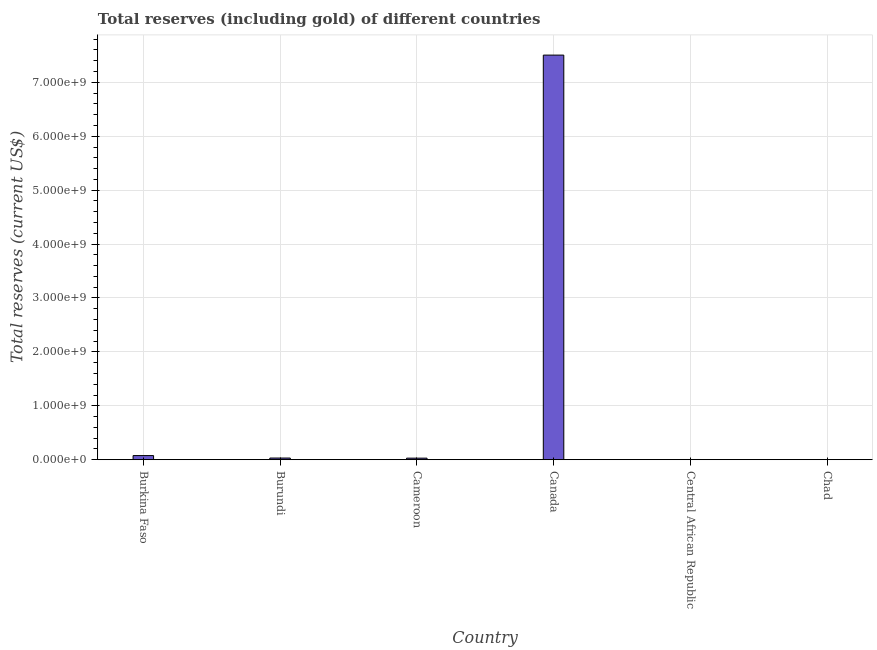What is the title of the graph?
Keep it short and to the point. Total reserves (including gold) of different countries. What is the label or title of the X-axis?
Offer a very short reply. Country. What is the label or title of the Y-axis?
Your response must be concise. Total reserves (current US$). What is the total reserves (including gold) in Central African Republic?
Give a very brief answer. 3.83e+06. Across all countries, what is the maximum total reserves (including gold)?
Keep it short and to the point. 7.50e+09. Across all countries, what is the minimum total reserves (including gold)?
Your response must be concise. 3.06e+06. In which country was the total reserves (including gold) maximum?
Provide a succinct answer. Canada. In which country was the total reserves (including gold) minimum?
Offer a terse response. Chad. What is the sum of the total reserves (including gold)?
Give a very brief answer. 7.65e+09. What is the difference between the total reserves (including gold) in Burundi and Chad?
Ensure brevity in your answer.  2.78e+07. What is the average total reserves (including gold) per country?
Make the answer very short. 1.27e+09. What is the median total reserves (including gold)?
Your answer should be very brief. 2.98e+07. In how many countries, is the total reserves (including gold) greater than 7200000000 US$?
Give a very brief answer. 1. What is the ratio of the total reserves (including gold) in Central African Republic to that in Chad?
Offer a very short reply. 1.25. What is the difference between the highest and the second highest total reserves (including gold)?
Ensure brevity in your answer.  7.43e+09. Is the sum of the total reserves (including gold) in Burkina Faso and Canada greater than the maximum total reserves (including gold) across all countries?
Offer a very short reply. Yes. What is the difference between the highest and the lowest total reserves (including gold)?
Offer a very short reply. 7.50e+09. What is the difference between two consecutive major ticks on the Y-axis?
Give a very brief answer. 1.00e+09. What is the Total reserves (current US$) of Burkina Faso?
Offer a terse response. 7.65e+07. What is the Total reserves (current US$) in Burundi?
Provide a short and direct response. 3.08e+07. What is the Total reserves (current US$) of Cameroon?
Provide a short and direct response. 2.88e+07. What is the Total reserves (current US$) of Canada?
Your answer should be compact. 7.50e+09. What is the Total reserves (current US$) of Central African Republic?
Ensure brevity in your answer.  3.83e+06. What is the Total reserves (current US$) of Chad?
Keep it short and to the point. 3.06e+06. What is the difference between the Total reserves (current US$) in Burkina Faso and Burundi?
Keep it short and to the point. 4.57e+07. What is the difference between the Total reserves (current US$) in Burkina Faso and Cameroon?
Make the answer very short. 4.77e+07. What is the difference between the Total reserves (current US$) in Burkina Faso and Canada?
Your answer should be compact. -7.43e+09. What is the difference between the Total reserves (current US$) in Burkina Faso and Central African Republic?
Give a very brief answer. 7.27e+07. What is the difference between the Total reserves (current US$) in Burkina Faso and Chad?
Provide a short and direct response. 7.35e+07. What is the difference between the Total reserves (current US$) in Burundi and Cameroon?
Provide a succinct answer. 2.02e+06. What is the difference between the Total reserves (current US$) in Burundi and Canada?
Your response must be concise. -7.47e+09. What is the difference between the Total reserves (current US$) in Burundi and Central African Republic?
Your answer should be very brief. 2.70e+07. What is the difference between the Total reserves (current US$) in Burundi and Chad?
Keep it short and to the point. 2.78e+07. What is the difference between the Total reserves (current US$) in Cameroon and Canada?
Keep it short and to the point. -7.48e+09. What is the difference between the Total reserves (current US$) in Cameroon and Central African Republic?
Offer a terse response. 2.50e+07. What is the difference between the Total reserves (current US$) in Cameroon and Chad?
Offer a very short reply. 2.58e+07. What is the difference between the Total reserves (current US$) in Canada and Central African Republic?
Give a very brief answer. 7.50e+09. What is the difference between the Total reserves (current US$) in Canada and Chad?
Your response must be concise. 7.50e+09. What is the difference between the Total reserves (current US$) in Central African Republic and Chad?
Your response must be concise. 7.70e+05. What is the ratio of the Total reserves (current US$) in Burkina Faso to that in Burundi?
Your answer should be very brief. 2.48. What is the ratio of the Total reserves (current US$) in Burkina Faso to that in Cameroon?
Your answer should be compact. 2.65. What is the ratio of the Total reserves (current US$) in Burkina Faso to that in Central African Republic?
Offer a very short reply. 19.99. What is the ratio of the Total reserves (current US$) in Burkina Faso to that in Chad?
Offer a terse response. 25.03. What is the ratio of the Total reserves (current US$) in Burundi to that in Cameroon?
Your response must be concise. 1.07. What is the ratio of the Total reserves (current US$) in Burundi to that in Canada?
Keep it short and to the point. 0. What is the ratio of the Total reserves (current US$) in Burundi to that in Central African Republic?
Offer a terse response. 8.06. What is the ratio of the Total reserves (current US$) in Burundi to that in Chad?
Provide a short and direct response. 10.09. What is the ratio of the Total reserves (current US$) in Cameroon to that in Canada?
Your answer should be compact. 0. What is the ratio of the Total reserves (current US$) in Cameroon to that in Central African Republic?
Offer a terse response. 7.53. What is the ratio of the Total reserves (current US$) in Cameroon to that in Chad?
Provide a short and direct response. 9.43. What is the ratio of the Total reserves (current US$) in Canada to that in Central African Republic?
Give a very brief answer. 1960.07. What is the ratio of the Total reserves (current US$) in Canada to that in Chad?
Keep it short and to the point. 2453.66. What is the ratio of the Total reserves (current US$) in Central African Republic to that in Chad?
Provide a succinct answer. 1.25. 